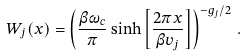<formula> <loc_0><loc_0><loc_500><loc_500>W _ { j } ( x ) = \left ( \frac { \beta \omega _ { c } } { \pi } \sinh \left [ \frac { 2 \pi x } { \beta v _ { j } } \right ] \right ) ^ { - g _ { j } / 2 } \, .</formula> 